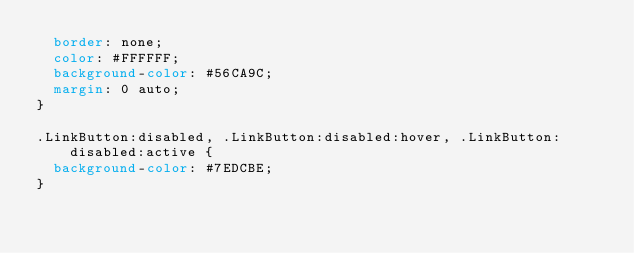Convert code to text. <code><loc_0><loc_0><loc_500><loc_500><_CSS_>  border: none;
  color: #FFFFFF;
  background-color: #56CA9C;
  margin: 0 auto;
}

.LinkButton:disabled, .LinkButton:disabled:hover, .LinkButton:disabled:active {
  background-color: #7EDCBE;
}
</code> 